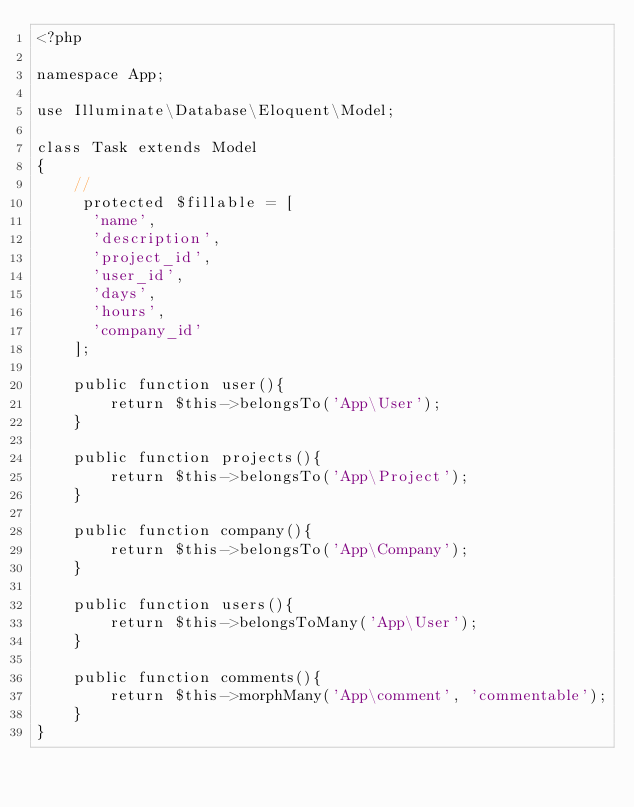Convert code to text. <code><loc_0><loc_0><loc_500><loc_500><_PHP_><?php

namespace App;

use Illuminate\Database\Eloquent\Model;

class Task extends Model
{
    //
     protected $fillable = [
    	'name',
    	'description',
    	'project_id',
    	'user_id',
    	'days',
    	'hours',
    	'company_id'
    ];

    public function user(){
        return $this->belongsTo('App\User');
    }

    public function projects(){
        return $this->belongsTo('App\Project');
    }

    public function company(){
        return $this->belongsTo('App\Company');
    }

    public function users(){
        return $this->belongsToMany('App\User');
    }

    public function comments(){
        return $this->morphMany('App\comment', 'commentable');
    }
}
</code> 